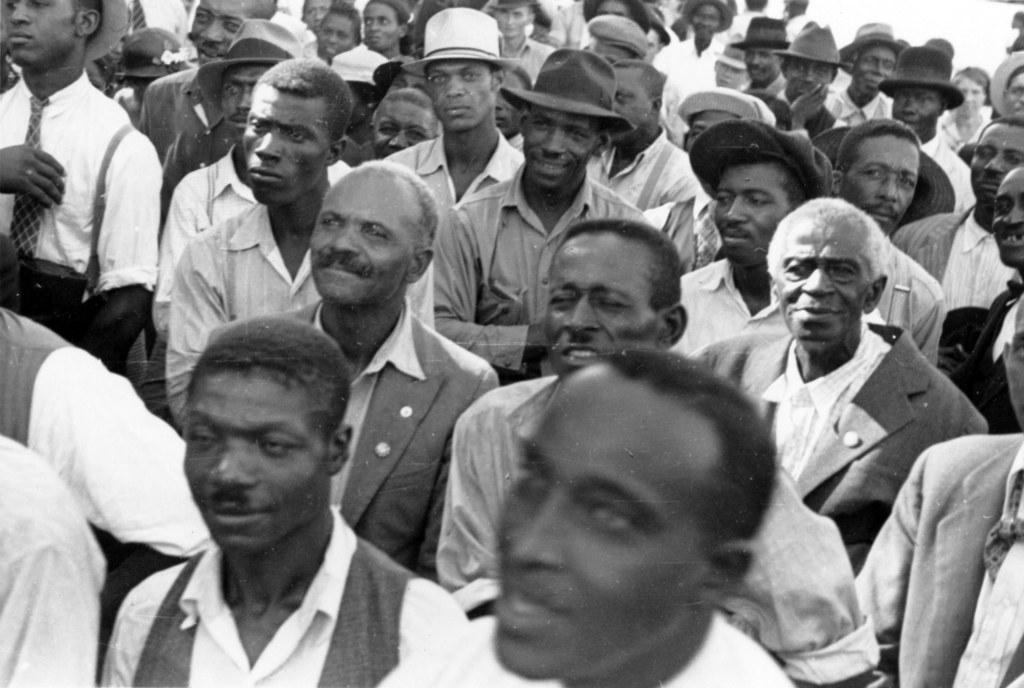Can you describe this image briefly? It is the black and white image in which we can see that there are so many people who are standing one beside the other in the group. There are few people in the middle who are wearing the caps. 